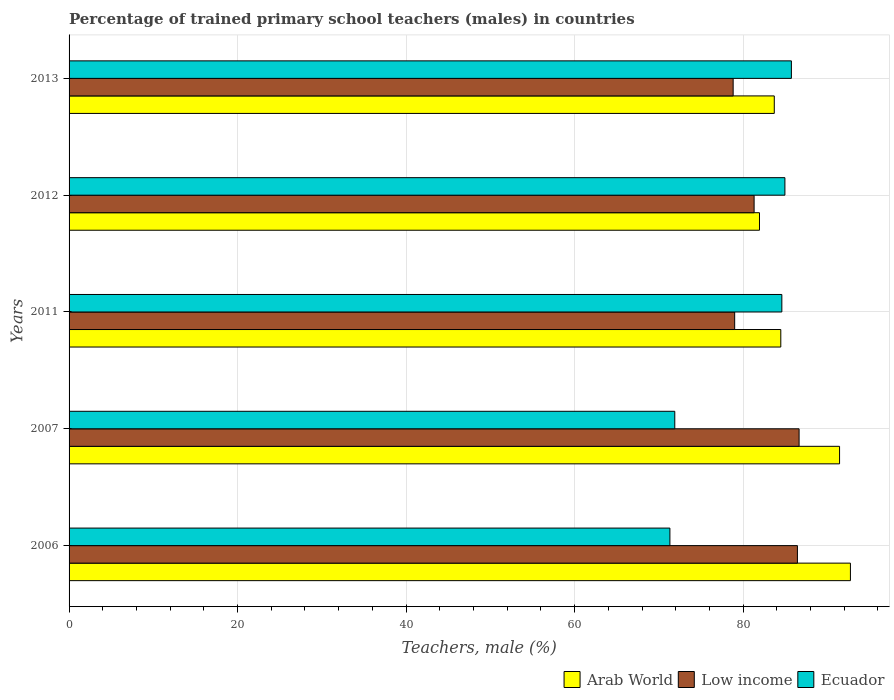How many different coloured bars are there?
Your answer should be compact. 3. How many groups of bars are there?
Give a very brief answer. 5. How many bars are there on the 3rd tick from the bottom?
Ensure brevity in your answer.  3. What is the label of the 1st group of bars from the top?
Your response must be concise. 2013. What is the percentage of trained primary school teachers (males) in Low income in 2012?
Your answer should be compact. 81.31. Across all years, what is the maximum percentage of trained primary school teachers (males) in Ecuador?
Make the answer very short. 85.73. Across all years, what is the minimum percentage of trained primary school teachers (males) in Low income?
Your response must be concise. 78.82. In which year was the percentage of trained primary school teachers (males) in Ecuador minimum?
Give a very brief answer. 2006. What is the total percentage of trained primary school teachers (males) in Low income in the graph?
Provide a short and direct response. 412.22. What is the difference between the percentage of trained primary school teachers (males) in Arab World in 2006 and that in 2013?
Your response must be concise. 9.04. What is the difference between the percentage of trained primary school teachers (males) in Low income in 2011 and the percentage of trained primary school teachers (males) in Ecuador in 2013?
Offer a very short reply. -6.73. What is the average percentage of trained primary school teachers (males) in Arab World per year?
Keep it short and to the point. 86.86. In the year 2013, what is the difference between the percentage of trained primary school teachers (males) in Arab World and percentage of trained primary school teachers (males) in Low income?
Your answer should be very brief. 4.88. In how many years, is the percentage of trained primary school teachers (males) in Arab World greater than 52 %?
Ensure brevity in your answer.  5. What is the ratio of the percentage of trained primary school teachers (males) in Ecuador in 2007 to that in 2013?
Offer a very short reply. 0.84. What is the difference between the highest and the second highest percentage of trained primary school teachers (males) in Arab World?
Provide a short and direct response. 1.29. What is the difference between the highest and the lowest percentage of trained primary school teachers (males) in Low income?
Ensure brevity in your answer.  7.83. In how many years, is the percentage of trained primary school teachers (males) in Arab World greater than the average percentage of trained primary school teachers (males) in Arab World taken over all years?
Offer a terse response. 2. Is the sum of the percentage of trained primary school teachers (males) in Arab World in 2006 and 2011 greater than the maximum percentage of trained primary school teachers (males) in Ecuador across all years?
Provide a short and direct response. Yes. What does the 1st bar from the top in 2013 represents?
Offer a very short reply. Ecuador. What does the 3rd bar from the bottom in 2013 represents?
Make the answer very short. Ecuador. How many bars are there?
Offer a terse response. 15. Are all the bars in the graph horizontal?
Give a very brief answer. Yes. Are the values on the major ticks of X-axis written in scientific E-notation?
Provide a short and direct response. No. Does the graph contain any zero values?
Keep it short and to the point. No. Where does the legend appear in the graph?
Provide a succinct answer. Bottom right. What is the title of the graph?
Provide a short and direct response. Percentage of trained primary school teachers (males) in countries. Does "Togo" appear as one of the legend labels in the graph?
Offer a terse response. No. What is the label or title of the X-axis?
Provide a short and direct response. Teachers, male (%). What is the label or title of the Y-axis?
Offer a very short reply. Years. What is the Teachers, male (%) of Arab World in 2006?
Keep it short and to the point. 92.74. What is the Teachers, male (%) of Low income in 2006?
Your response must be concise. 86.45. What is the Teachers, male (%) of Ecuador in 2006?
Provide a short and direct response. 71.31. What is the Teachers, male (%) in Arab World in 2007?
Your answer should be compact. 91.45. What is the Teachers, male (%) of Low income in 2007?
Give a very brief answer. 86.65. What is the Teachers, male (%) in Ecuador in 2007?
Keep it short and to the point. 71.89. What is the Teachers, male (%) of Arab World in 2011?
Give a very brief answer. 84.47. What is the Teachers, male (%) of Low income in 2011?
Provide a succinct answer. 79. What is the Teachers, male (%) in Ecuador in 2011?
Your answer should be compact. 84.6. What is the Teachers, male (%) in Arab World in 2012?
Offer a terse response. 81.94. What is the Teachers, male (%) of Low income in 2012?
Make the answer very short. 81.31. What is the Teachers, male (%) in Ecuador in 2012?
Give a very brief answer. 84.96. What is the Teachers, male (%) of Arab World in 2013?
Provide a succinct answer. 83.7. What is the Teachers, male (%) in Low income in 2013?
Provide a succinct answer. 78.82. What is the Teachers, male (%) in Ecuador in 2013?
Offer a very short reply. 85.73. Across all years, what is the maximum Teachers, male (%) of Arab World?
Provide a short and direct response. 92.74. Across all years, what is the maximum Teachers, male (%) of Low income?
Provide a succinct answer. 86.65. Across all years, what is the maximum Teachers, male (%) of Ecuador?
Offer a very short reply. 85.73. Across all years, what is the minimum Teachers, male (%) of Arab World?
Your answer should be very brief. 81.94. Across all years, what is the minimum Teachers, male (%) of Low income?
Provide a succinct answer. 78.82. Across all years, what is the minimum Teachers, male (%) of Ecuador?
Your answer should be very brief. 71.31. What is the total Teachers, male (%) in Arab World in the graph?
Make the answer very short. 434.31. What is the total Teachers, male (%) of Low income in the graph?
Your answer should be very brief. 412.22. What is the total Teachers, male (%) of Ecuador in the graph?
Ensure brevity in your answer.  398.5. What is the difference between the Teachers, male (%) in Arab World in 2006 and that in 2007?
Offer a very short reply. 1.29. What is the difference between the Teachers, male (%) of Low income in 2006 and that in 2007?
Your response must be concise. -0.2. What is the difference between the Teachers, male (%) in Ecuador in 2006 and that in 2007?
Your answer should be compact. -0.58. What is the difference between the Teachers, male (%) of Arab World in 2006 and that in 2011?
Your answer should be very brief. 8.26. What is the difference between the Teachers, male (%) of Low income in 2006 and that in 2011?
Offer a very short reply. 7.45. What is the difference between the Teachers, male (%) in Ecuador in 2006 and that in 2011?
Offer a very short reply. -13.29. What is the difference between the Teachers, male (%) in Arab World in 2006 and that in 2012?
Offer a terse response. 10.79. What is the difference between the Teachers, male (%) in Low income in 2006 and that in 2012?
Your answer should be compact. 5.14. What is the difference between the Teachers, male (%) of Ecuador in 2006 and that in 2012?
Ensure brevity in your answer.  -13.65. What is the difference between the Teachers, male (%) in Arab World in 2006 and that in 2013?
Give a very brief answer. 9.04. What is the difference between the Teachers, male (%) in Low income in 2006 and that in 2013?
Offer a terse response. 7.63. What is the difference between the Teachers, male (%) in Ecuador in 2006 and that in 2013?
Your response must be concise. -14.42. What is the difference between the Teachers, male (%) of Arab World in 2007 and that in 2011?
Offer a very short reply. 6.97. What is the difference between the Teachers, male (%) in Low income in 2007 and that in 2011?
Your answer should be very brief. 7.65. What is the difference between the Teachers, male (%) of Ecuador in 2007 and that in 2011?
Offer a very short reply. -12.71. What is the difference between the Teachers, male (%) in Arab World in 2007 and that in 2012?
Ensure brevity in your answer.  9.5. What is the difference between the Teachers, male (%) of Low income in 2007 and that in 2012?
Give a very brief answer. 5.34. What is the difference between the Teachers, male (%) in Ecuador in 2007 and that in 2012?
Keep it short and to the point. -13.07. What is the difference between the Teachers, male (%) of Arab World in 2007 and that in 2013?
Your answer should be compact. 7.75. What is the difference between the Teachers, male (%) in Low income in 2007 and that in 2013?
Offer a terse response. 7.83. What is the difference between the Teachers, male (%) in Ecuador in 2007 and that in 2013?
Keep it short and to the point. -13.84. What is the difference between the Teachers, male (%) of Arab World in 2011 and that in 2012?
Keep it short and to the point. 2.53. What is the difference between the Teachers, male (%) in Low income in 2011 and that in 2012?
Give a very brief answer. -2.31. What is the difference between the Teachers, male (%) of Ecuador in 2011 and that in 2012?
Your response must be concise. -0.36. What is the difference between the Teachers, male (%) in Arab World in 2011 and that in 2013?
Provide a short and direct response. 0.77. What is the difference between the Teachers, male (%) in Low income in 2011 and that in 2013?
Your response must be concise. 0.18. What is the difference between the Teachers, male (%) in Ecuador in 2011 and that in 2013?
Make the answer very short. -1.13. What is the difference between the Teachers, male (%) of Arab World in 2012 and that in 2013?
Your answer should be compact. -1.76. What is the difference between the Teachers, male (%) of Low income in 2012 and that in 2013?
Ensure brevity in your answer.  2.49. What is the difference between the Teachers, male (%) in Ecuador in 2012 and that in 2013?
Your response must be concise. -0.77. What is the difference between the Teachers, male (%) of Arab World in 2006 and the Teachers, male (%) of Low income in 2007?
Offer a very short reply. 6.09. What is the difference between the Teachers, male (%) of Arab World in 2006 and the Teachers, male (%) of Ecuador in 2007?
Your response must be concise. 20.85. What is the difference between the Teachers, male (%) in Low income in 2006 and the Teachers, male (%) in Ecuador in 2007?
Provide a short and direct response. 14.56. What is the difference between the Teachers, male (%) in Arab World in 2006 and the Teachers, male (%) in Low income in 2011?
Ensure brevity in your answer.  13.74. What is the difference between the Teachers, male (%) of Arab World in 2006 and the Teachers, male (%) of Ecuador in 2011?
Make the answer very short. 8.14. What is the difference between the Teachers, male (%) of Low income in 2006 and the Teachers, male (%) of Ecuador in 2011?
Keep it short and to the point. 1.85. What is the difference between the Teachers, male (%) in Arab World in 2006 and the Teachers, male (%) in Low income in 2012?
Your answer should be very brief. 11.43. What is the difference between the Teachers, male (%) of Arab World in 2006 and the Teachers, male (%) of Ecuador in 2012?
Your answer should be compact. 7.78. What is the difference between the Teachers, male (%) of Low income in 2006 and the Teachers, male (%) of Ecuador in 2012?
Your response must be concise. 1.48. What is the difference between the Teachers, male (%) of Arab World in 2006 and the Teachers, male (%) of Low income in 2013?
Ensure brevity in your answer.  13.92. What is the difference between the Teachers, male (%) in Arab World in 2006 and the Teachers, male (%) in Ecuador in 2013?
Offer a very short reply. 7.01. What is the difference between the Teachers, male (%) of Low income in 2006 and the Teachers, male (%) of Ecuador in 2013?
Offer a very short reply. 0.71. What is the difference between the Teachers, male (%) in Arab World in 2007 and the Teachers, male (%) in Low income in 2011?
Your response must be concise. 12.45. What is the difference between the Teachers, male (%) in Arab World in 2007 and the Teachers, male (%) in Ecuador in 2011?
Keep it short and to the point. 6.85. What is the difference between the Teachers, male (%) of Low income in 2007 and the Teachers, male (%) of Ecuador in 2011?
Your response must be concise. 2.05. What is the difference between the Teachers, male (%) of Arab World in 2007 and the Teachers, male (%) of Low income in 2012?
Provide a short and direct response. 10.14. What is the difference between the Teachers, male (%) of Arab World in 2007 and the Teachers, male (%) of Ecuador in 2012?
Make the answer very short. 6.49. What is the difference between the Teachers, male (%) in Low income in 2007 and the Teachers, male (%) in Ecuador in 2012?
Give a very brief answer. 1.68. What is the difference between the Teachers, male (%) in Arab World in 2007 and the Teachers, male (%) in Low income in 2013?
Provide a succinct answer. 12.63. What is the difference between the Teachers, male (%) of Arab World in 2007 and the Teachers, male (%) of Ecuador in 2013?
Your answer should be very brief. 5.72. What is the difference between the Teachers, male (%) of Low income in 2007 and the Teachers, male (%) of Ecuador in 2013?
Make the answer very short. 0.91. What is the difference between the Teachers, male (%) in Arab World in 2011 and the Teachers, male (%) in Low income in 2012?
Ensure brevity in your answer.  3.17. What is the difference between the Teachers, male (%) in Arab World in 2011 and the Teachers, male (%) in Ecuador in 2012?
Ensure brevity in your answer.  -0.49. What is the difference between the Teachers, male (%) of Low income in 2011 and the Teachers, male (%) of Ecuador in 2012?
Offer a very short reply. -5.96. What is the difference between the Teachers, male (%) of Arab World in 2011 and the Teachers, male (%) of Low income in 2013?
Your answer should be compact. 5.65. What is the difference between the Teachers, male (%) in Arab World in 2011 and the Teachers, male (%) in Ecuador in 2013?
Provide a succinct answer. -1.26. What is the difference between the Teachers, male (%) of Low income in 2011 and the Teachers, male (%) of Ecuador in 2013?
Make the answer very short. -6.73. What is the difference between the Teachers, male (%) of Arab World in 2012 and the Teachers, male (%) of Low income in 2013?
Make the answer very short. 3.12. What is the difference between the Teachers, male (%) in Arab World in 2012 and the Teachers, male (%) in Ecuador in 2013?
Provide a succinct answer. -3.79. What is the difference between the Teachers, male (%) of Low income in 2012 and the Teachers, male (%) of Ecuador in 2013?
Your response must be concise. -4.43. What is the average Teachers, male (%) in Arab World per year?
Your response must be concise. 86.86. What is the average Teachers, male (%) of Low income per year?
Your answer should be compact. 82.44. What is the average Teachers, male (%) of Ecuador per year?
Your response must be concise. 79.7. In the year 2006, what is the difference between the Teachers, male (%) in Arab World and Teachers, male (%) in Low income?
Your response must be concise. 6.29. In the year 2006, what is the difference between the Teachers, male (%) in Arab World and Teachers, male (%) in Ecuador?
Your answer should be compact. 21.43. In the year 2006, what is the difference between the Teachers, male (%) in Low income and Teachers, male (%) in Ecuador?
Your answer should be very brief. 15.13. In the year 2007, what is the difference between the Teachers, male (%) of Arab World and Teachers, male (%) of Low income?
Your answer should be very brief. 4.8. In the year 2007, what is the difference between the Teachers, male (%) in Arab World and Teachers, male (%) in Ecuador?
Keep it short and to the point. 19.56. In the year 2007, what is the difference between the Teachers, male (%) of Low income and Teachers, male (%) of Ecuador?
Ensure brevity in your answer.  14.76. In the year 2011, what is the difference between the Teachers, male (%) of Arab World and Teachers, male (%) of Low income?
Provide a short and direct response. 5.48. In the year 2011, what is the difference between the Teachers, male (%) of Arab World and Teachers, male (%) of Ecuador?
Your answer should be very brief. -0.12. In the year 2011, what is the difference between the Teachers, male (%) of Low income and Teachers, male (%) of Ecuador?
Your answer should be very brief. -5.6. In the year 2012, what is the difference between the Teachers, male (%) of Arab World and Teachers, male (%) of Low income?
Ensure brevity in your answer.  0.64. In the year 2012, what is the difference between the Teachers, male (%) in Arab World and Teachers, male (%) in Ecuador?
Give a very brief answer. -3.02. In the year 2012, what is the difference between the Teachers, male (%) in Low income and Teachers, male (%) in Ecuador?
Offer a very short reply. -3.65. In the year 2013, what is the difference between the Teachers, male (%) in Arab World and Teachers, male (%) in Low income?
Your answer should be very brief. 4.88. In the year 2013, what is the difference between the Teachers, male (%) of Arab World and Teachers, male (%) of Ecuador?
Offer a very short reply. -2.03. In the year 2013, what is the difference between the Teachers, male (%) of Low income and Teachers, male (%) of Ecuador?
Your answer should be very brief. -6.91. What is the ratio of the Teachers, male (%) in Arab World in 2006 to that in 2007?
Offer a terse response. 1.01. What is the ratio of the Teachers, male (%) of Low income in 2006 to that in 2007?
Your answer should be very brief. 1. What is the ratio of the Teachers, male (%) in Arab World in 2006 to that in 2011?
Your answer should be very brief. 1.1. What is the ratio of the Teachers, male (%) of Low income in 2006 to that in 2011?
Ensure brevity in your answer.  1.09. What is the ratio of the Teachers, male (%) in Ecuador in 2006 to that in 2011?
Your answer should be very brief. 0.84. What is the ratio of the Teachers, male (%) of Arab World in 2006 to that in 2012?
Your answer should be compact. 1.13. What is the ratio of the Teachers, male (%) of Low income in 2006 to that in 2012?
Ensure brevity in your answer.  1.06. What is the ratio of the Teachers, male (%) in Ecuador in 2006 to that in 2012?
Provide a short and direct response. 0.84. What is the ratio of the Teachers, male (%) in Arab World in 2006 to that in 2013?
Ensure brevity in your answer.  1.11. What is the ratio of the Teachers, male (%) in Low income in 2006 to that in 2013?
Offer a very short reply. 1.1. What is the ratio of the Teachers, male (%) in Ecuador in 2006 to that in 2013?
Give a very brief answer. 0.83. What is the ratio of the Teachers, male (%) of Arab World in 2007 to that in 2011?
Give a very brief answer. 1.08. What is the ratio of the Teachers, male (%) in Low income in 2007 to that in 2011?
Provide a succinct answer. 1.1. What is the ratio of the Teachers, male (%) in Ecuador in 2007 to that in 2011?
Offer a terse response. 0.85. What is the ratio of the Teachers, male (%) in Arab World in 2007 to that in 2012?
Provide a short and direct response. 1.12. What is the ratio of the Teachers, male (%) in Low income in 2007 to that in 2012?
Offer a very short reply. 1.07. What is the ratio of the Teachers, male (%) of Ecuador in 2007 to that in 2012?
Provide a short and direct response. 0.85. What is the ratio of the Teachers, male (%) of Arab World in 2007 to that in 2013?
Keep it short and to the point. 1.09. What is the ratio of the Teachers, male (%) in Low income in 2007 to that in 2013?
Keep it short and to the point. 1.1. What is the ratio of the Teachers, male (%) of Ecuador in 2007 to that in 2013?
Provide a succinct answer. 0.84. What is the ratio of the Teachers, male (%) in Arab World in 2011 to that in 2012?
Your response must be concise. 1.03. What is the ratio of the Teachers, male (%) in Low income in 2011 to that in 2012?
Ensure brevity in your answer.  0.97. What is the ratio of the Teachers, male (%) of Arab World in 2011 to that in 2013?
Keep it short and to the point. 1.01. What is the ratio of the Teachers, male (%) in Low income in 2011 to that in 2013?
Provide a short and direct response. 1. What is the ratio of the Teachers, male (%) in Ecuador in 2011 to that in 2013?
Keep it short and to the point. 0.99. What is the ratio of the Teachers, male (%) of Arab World in 2012 to that in 2013?
Give a very brief answer. 0.98. What is the ratio of the Teachers, male (%) of Low income in 2012 to that in 2013?
Your answer should be very brief. 1.03. What is the difference between the highest and the second highest Teachers, male (%) of Arab World?
Ensure brevity in your answer.  1.29. What is the difference between the highest and the second highest Teachers, male (%) in Low income?
Your response must be concise. 0.2. What is the difference between the highest and the second highest Teachers, male (%) in Ecuador?
Offer a very short reply. 0.77. What is the difference between the highest and the lowest Teachers, male (%) in Arab World?
Keep it short and to the point. 10.79. What is the difference between the highest and the lowest Teachers, male (%) of Low income?
Ensure brevity in your answer.  7.83. What is the difference between the highest and the lowest Teachers, male (%) in Ecuador?
Your response must be concise. 14.42. 